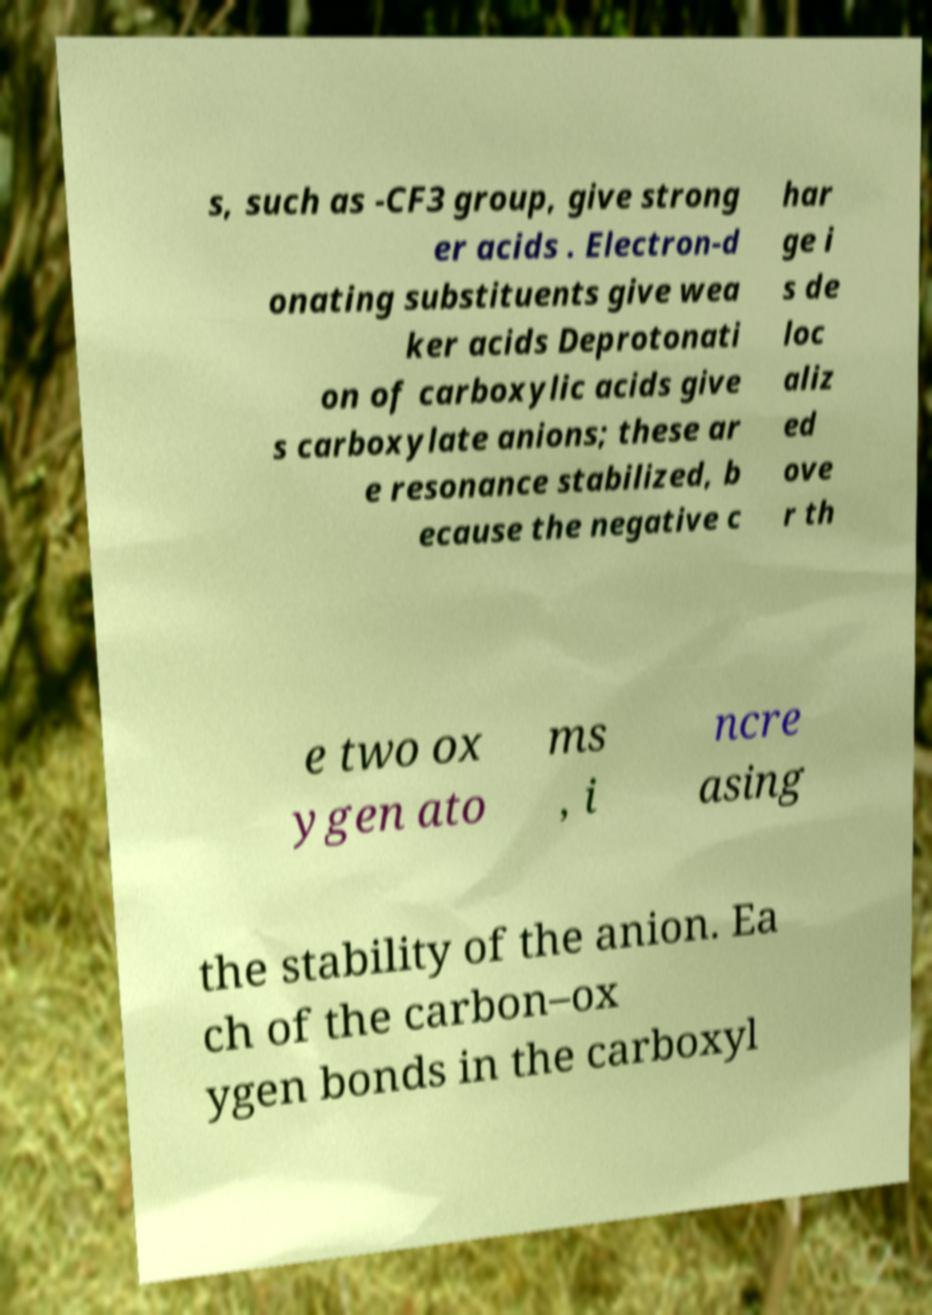What messages or text are displayed in this image? I need them in a readable, typed format. s, such as -CF3 group, give strong er acids . Electron-d onating substituents give wea ker acids Deprotonati on of carboxylic acids give s carboxylate anions; these ar e resonance stabilized, b ecause the negative c har ge i s de loc aliz ed ove r th e two ox ygen ato ms , i ncre asing the stability of the anion. Ea ch of the carbon–ox ygen bonds in the carboxyl 